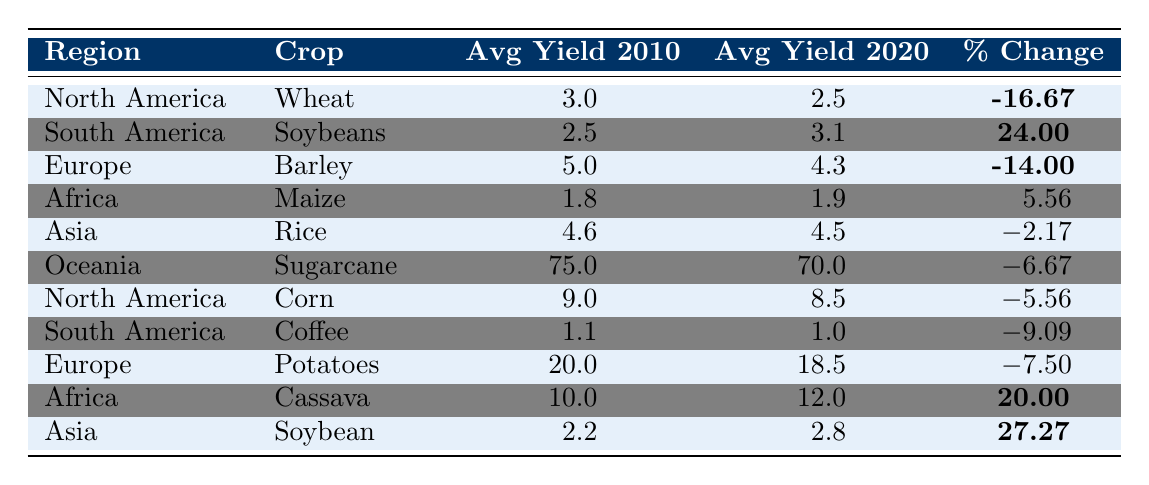What was the average yield of Wheat in North America in 2010? According to the table, the average yield of Wheat in North America in 2010 is directly listed as 3.0.
Answer: 3.0 What is the percentage change in average yield for Soybeans in South America from 2010 to 2020? The table shows that the percentage change for Soybeans in South America is highlighted as 24.00.
Answer: 24.00 Did the average yield of Maize in Africa increase or decrease from 2010 to 2020? The average yield of Maize in Africa increased from 1.8 in 2010 to 1.9 in 2020, which indicates an increase.
Answer: Increase Which crop saw the largest percentage decrease in yield in North America? The table indicates that Wheat experienced the largest percentage decrease at -16.67%.
Answer: Wheat What is the average yield of Cassava in Africa in 2020? Referring to the table, the average yield of Cassava in Africa in 2020 is 12.0.
Answer: 12.0 What was the percentage change for Potatoes in Europe compared to Soybean in Asia? Potatoes in Europe had a percentage change of -7.50, while Soybean in Asia had a percentage change of 27.27. The percentage change for Soybean is greater.
Answer: Soybean has a greater percentage change What was the average yield of Sugarcane in Oceania in 2010 compared to the average yield of Corn in North America in 2020? The average yield of Sugarcane in Oceania in 2010 is 75.0, and the average yield of Corn in North America in 2020 is 8.5. Comparing both values, Sugarcane's yield is higher.
Answer: Sugarcane's yield is higher Which region reported an increase in average yield for both Maize and Cassava? According to the table, Africa reported an increase in average yield for both Maize (from 1.8 to 1.9) and Cassava (from 10.0 to 12.0).
Answer: Africa Based on the data, which crop in North America had a smaller percentage decline: Wheat or Corn? The percentage decline for Wheat is -16.67%, whereas Corn had a decline of -5.56%. Thus, Corn had a smaller decline.
Answer: Corn What is the overall trend in average yields for crops in the table from 2010 to 2020? Analyzing the percentage changes, most crops show a decline, with notable exceptions like Soybeans and Cassava that increased. Thus, the overall trend points to a decline for many crops.
Answer: Overall decline Which crop had the highest average yield in 2010? The highest average yield in 2010 belongs to Sugarcane in Oceania, with an average yield of 75.0.
Answer: Sugarcane 